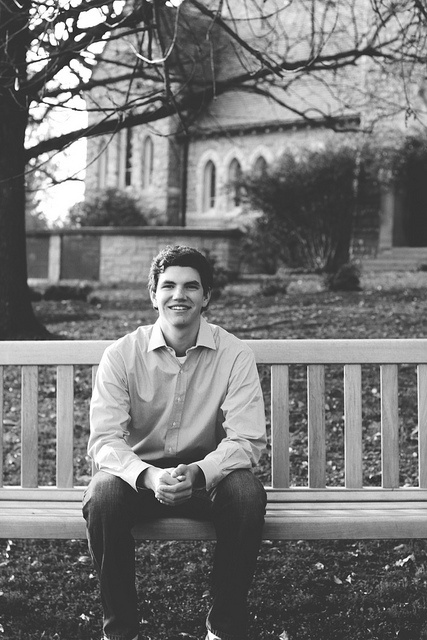Describe the objects in this image and their specific colors. I can see bench in gray, darkgray, lightgray, and black tones and people in gray, black, darkgray, and lightgray tones in this image. 